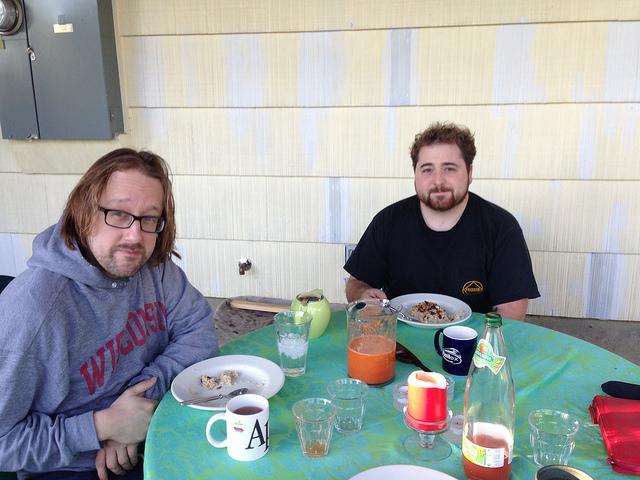Is the tall bottle on the table almost full?
Concise answer only. No. What state is on the mans sweater?
Give a very brief answer. Wisconsin. How many people are wearing glasses?
Give a very brief answer. 1. 